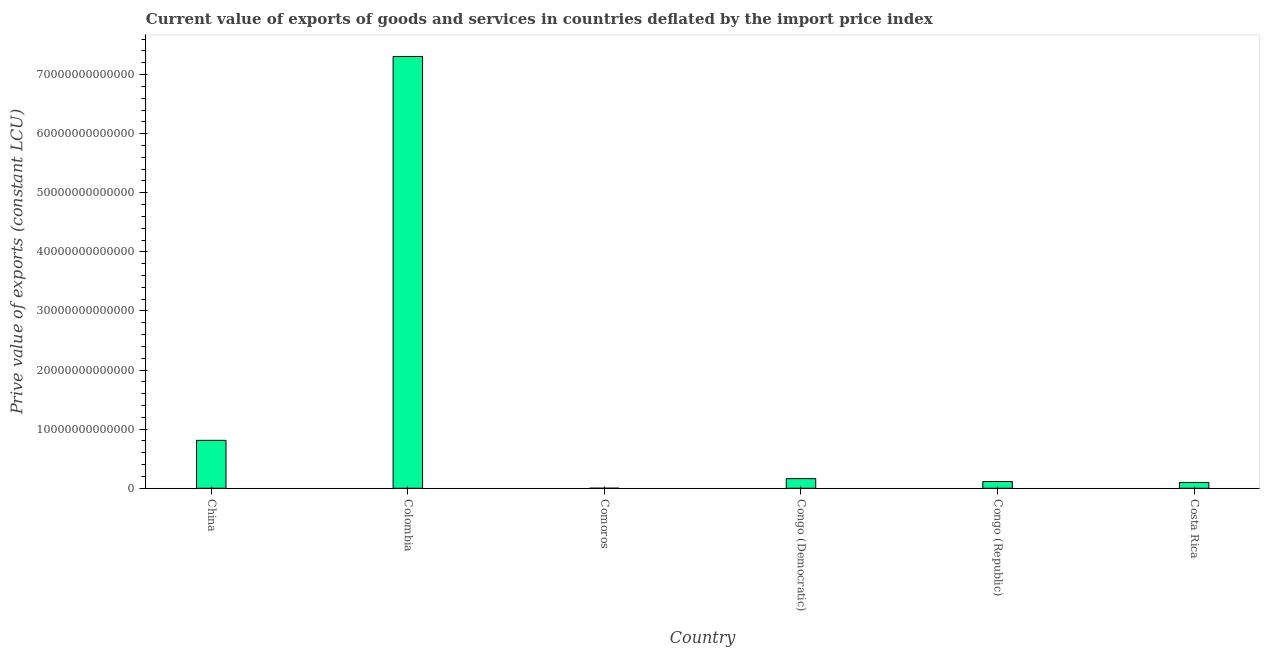Does the graph contain any zero values?
Make the answer very short. No. Does the graph contain grids?
Ensure brevity in your answer.  No. What is the title of the graph?
Make the answer very short. Current value of exports of goods and services in countries deflated by the import price index. What is the label or title of the X-axis?
Keep it short and to the point. Country. What is the label or title of the Y-axis?
Offer a terse response. Prive value of exports (constant LCU). What is the price value of exports in Comoros?
Provide a short and direct response. 1.25e+1. Across all countries, what is the maximum price value of exports?
Provide a short and direct response. 7.31e+13. Across all countries, what is the minimum price value of exports?
Provide a short and direct response. 1.25e+1. In which country was the price value of exports maximum?
Keep it short and to the point. Colombia. In which country was the price value of exports minimum?
Offer a terse response. Comoros. What is the sum of the price value of exports?
Offer a terse response. 8.50e+13. What is the difference between the price value of exports in Congo (Democratic) and Congo (Republic)?
Your answer should be very brief. 4.87e+11. What is the average price value of exports per country?
Your answer should be compact. 1.42e+13. What is the median price value of exports?
Give a very brief answer. 1.39e+12. What is the ratio of the price value of exports in China to that in Costa Rica?
Give a very brief answer. 8.21. Is the price value of exports in Colombia less than that in Congo (Republic)?
Give a very brief answer. No. What is the difference between the highest and the second highest price value of exports?
Your response must be concise. 6.49e+13. Is the sum of the price value of exports in China and Costa Rica greater than the maximum price value of exports across all countries?
Keep it short and to the point. No. What is the difference between the highest and the lowest price value of exports?
Provide a succinct answer. 7.30e+13. How many bars are there?
Keep it short and to the point. 6. What is the difference between two consecutive major ticks on the Y-axis?
Offer a terse response. 1.00e+13. What is the Prive value of exports (constant LCU) of China?
Your answer should be compact. 8.11e+12. What is the Prive value of exports (constant LCU) in Colombia?
Keep it short and to the point. 7.31e+13. What is the Prive value of exports (constant LCU) of Comoros?
Make the answer very short. 1.25e+1. What is the Prive value of exports (constant LCU) in Congo (Democratic)?
Make the answer very short. 1.64e+12. What is the Prive value of exports (constant LCU) in Congo (Republic)?
Keep it short and to the point. 1.15e+12. What is the Prive value of exports (constant LCU) in Costa Rica?
Provide a succinct answer. 9.88e+11. What is the difference between the Prive value of exports (constant LCU) in China and Colombia?
Offer a very short reply. -6.49e+13. What is the difference between the Prive value of exports (constant LCU) in China and Comoros?
Provide a short and direct response. 8.10e+12. What is the difference between the Prive value of exports (constant LCU) in China and Congo (Democratic)?
Offer a very short reply. 6.48e+12. What is the difference between the Prive value of exports (constant LCU) in China and Congo (Republic)?
Make the answer very short. 6.96e+12. What is the difference between the Prive value of exports (constant LCU) in China and Costa Rica?
Provide a short and direct response. 7.12e+12. What is the difference between the Prive value of exports (constant LCU) in Colombia and Comoros?
Provide a succinct answer. 7.30e+13. What is the difference between the Prive value of exports (constant LCU) in Colombia and Congo (Democratic)?
Your answer should be compact. 7.14e+13. What is the difference between the Prive value of exports (constant LCU) in Colombia and Congo (Republic)?
Give a very brief answer. 7.19e+13. What is the difference between the Prive value of exports (constant LCU) in Colombia and Costa Rica?
Your answer should be very brief. 7.21e+13. What is the difference between the Prive value of exports (constant LCU) in Comoros and Congo (Democratic)?
Keep it short and to the point. -1.62e+12. What is the difference between the Prive value of exports (constant LCU) in Comoros and Congo (Republic)?
Your answer should be very brief. -1.14e+12. What is the difference between the Prive value of exports (constant LCU) in Comoros and Costa Rica?
Offer a very short reply. -9.76e+11. What is the difference between the Prive value of exports (constant LCU) in Congo (Democratic) and Congo (Republic)?
Offer a terse response. 4.87e+11. What is the difference between the Prive value of exports (constant LCU) in Congo (Democratic) and Costa Rica?
Your response must be concise. 6.48e+11. What is the difference between the Prive value of exports (constant LCU) in Congo (Republic) and Costa Rica?
Your response must be concise. 1.61e+11. What is the ratio of the Prive value of exports (constant LCU) in China to that in Colombia?
Offer a very short reply. 0.11. What is the ratio of the Prive value of exports (constant LCU) in China to that in Comoros?
Make the answer very short. 651.49. What is the ratio of the Prive value of exports (constant LCU) in China to that in Congo (Democratic)?
Make the answer very short. 4.96. What is the ratio of the Prive value of exports (constant LCU) in China to that in Congo (Republic)?
Provide a succinct answer. 7.06. What is the ratio of the Prive value of exports (constant LCU) in China to that in Costa Rica?
Make the answer very short. 8.21. What is the ratio of the Prive value of exports (constant LCU) in Colombia to that in Comoros?
Provide a short and direct response. 5866.99. What is the ratio of the Prive value of exports (constant LCU) in Colombia to that in Congo (Democratic)?
Make the answer very short. 44.66. What is the ratio of the Prive value of exports (constant LCU) in Colombia to that in Congo (Republic)?
Give a very brief answer. 63.58. What is the ratio of the Prive value of exports (constant LCU) in Colombia to that in Costa Rica?
Provide a succinct answer. 73.95. What is the ratio of the Prive value of exports (constant LCU) in Comoros to that in Congo (Democratic)?
Your answer should be compact. 0.01. What is the ratio of the Prive value of exports (constant LCU) in Comoros to that in Congo (Republic)?
Offer a terse response. 0.01. What is the ratio of the Prive value of exports (constant LCU) in Comoros to that in Costa Rica?
Give a very brief answer. 0.01. What is the ratio of the Prive value of exports (constant LCU) in Congo (Democratic) to that in Congo (Republic)?
Provide a short and direct response. 1.42. What is the ratio of the Prive value of exports (constant LCU) in Congo (Democratic) to that in Costa Rica?
Keep it short and to the point. 1.66. What is the ratio of the Prive value of exports (constant LCU) in Congo (Republic) to that in Costa Rica?
Make the answer very short. 1.16. 